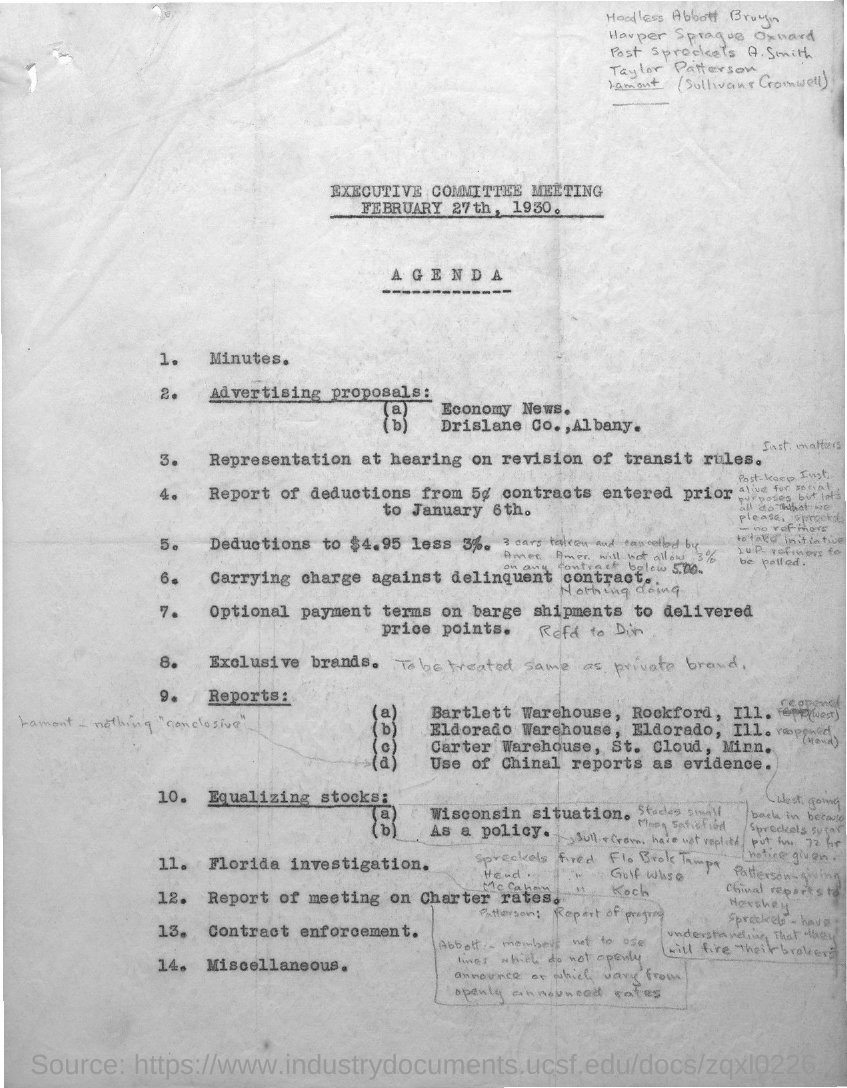Identify some key points in this picture. The date of the meeting is February 27th, 1930. 